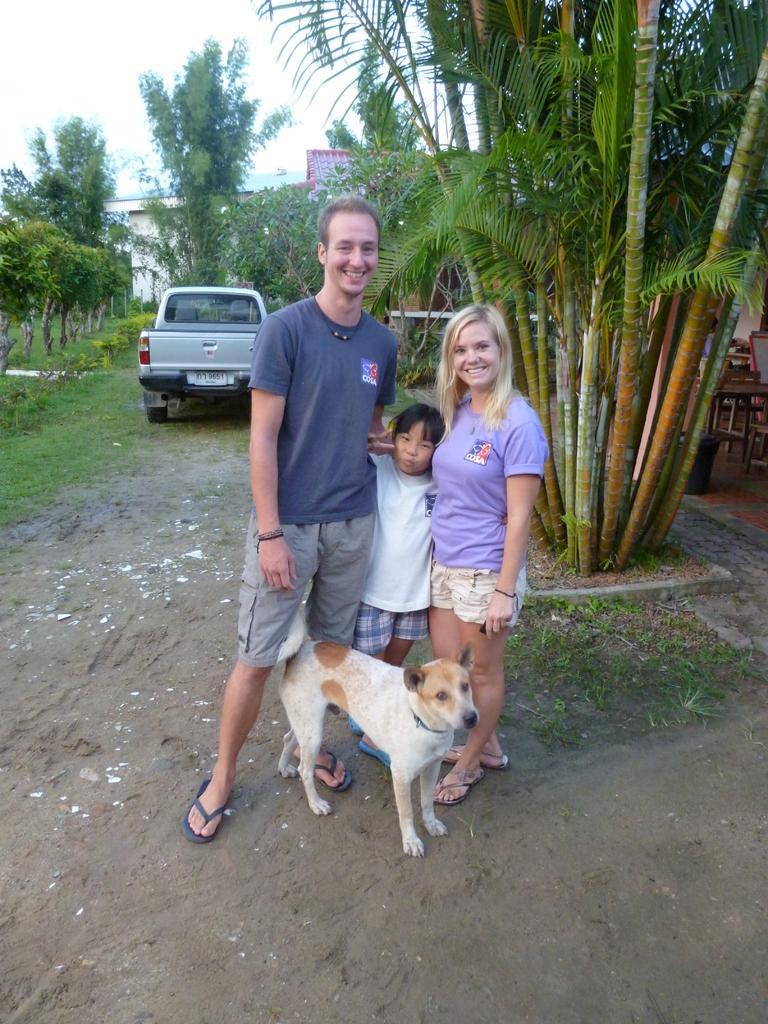Can you describe this image briefly? Here I can see a man, a woman and a girl are wearing t-shirts, shorts, standing on the ground, smiling and giving pose for the picture. In front of these people there is a dog. In the background, I can see a truck, trees and building. At the top of the image I can see the sky. 